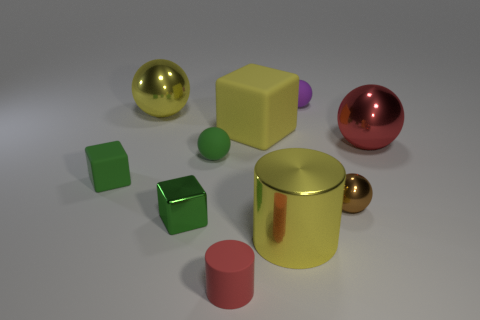There is a metallic ball on the left side of the tiny purple object; does it have the same size as the cylinder behind the red cylinder?
Keep it short and to the point. Yes. What number of other objects are the same color as the shiny cylinder?
Offer a terse response. 2. Does the brown metal object have the same size as the cylinder that is right of the tiny red thing?
Make the answer very short. No. There is a matte ball that is behind the big ball that is behind the big red shiny sphere; what is its size?
Ensure brevity in your answer.  Small. What color is the other large shiny object that is the same shape as the large red metallic object?
Your answer should be very brief. Yellow. Is the size of the purple rubber object the same as the brown ball?
Keep it short and to the point. Yes. Are there an equal number of large metallic objects behind the big yellow matte thing and large spheres?
Offer a very short reply. No. There is a yellow metallic thing behind the red ball; is there a tiny matte object that is behind it?
Keep it short and to the point. Yes. There is a red object on the right side of the matte cube that is behind the tiny rubber sphere that is on the left side of the big yellow metal cylinder; what is its size?
Provide a succinct answer. Large. There is a big ball that is to the right of the tiny rubber sphere that is left of the purple sphere; what is it made of?
Your answer should be compact. Metal. 